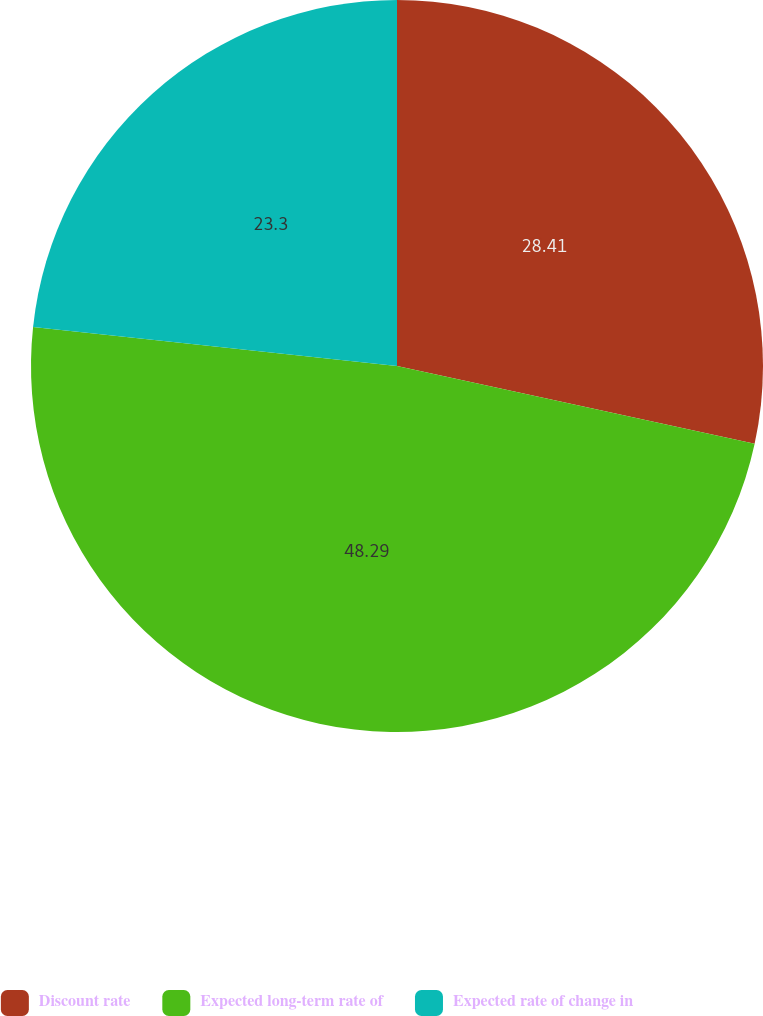<chart> <loc_0><loc_0><loc_500><loc_500><pie_chart><fcel>Discount rate<fcel>Expected long-term rate of<fcel>Expected rate of change in<nl><fcel>28.41%<fcel>48.3%<fcel>23.3%<nl></chart> 